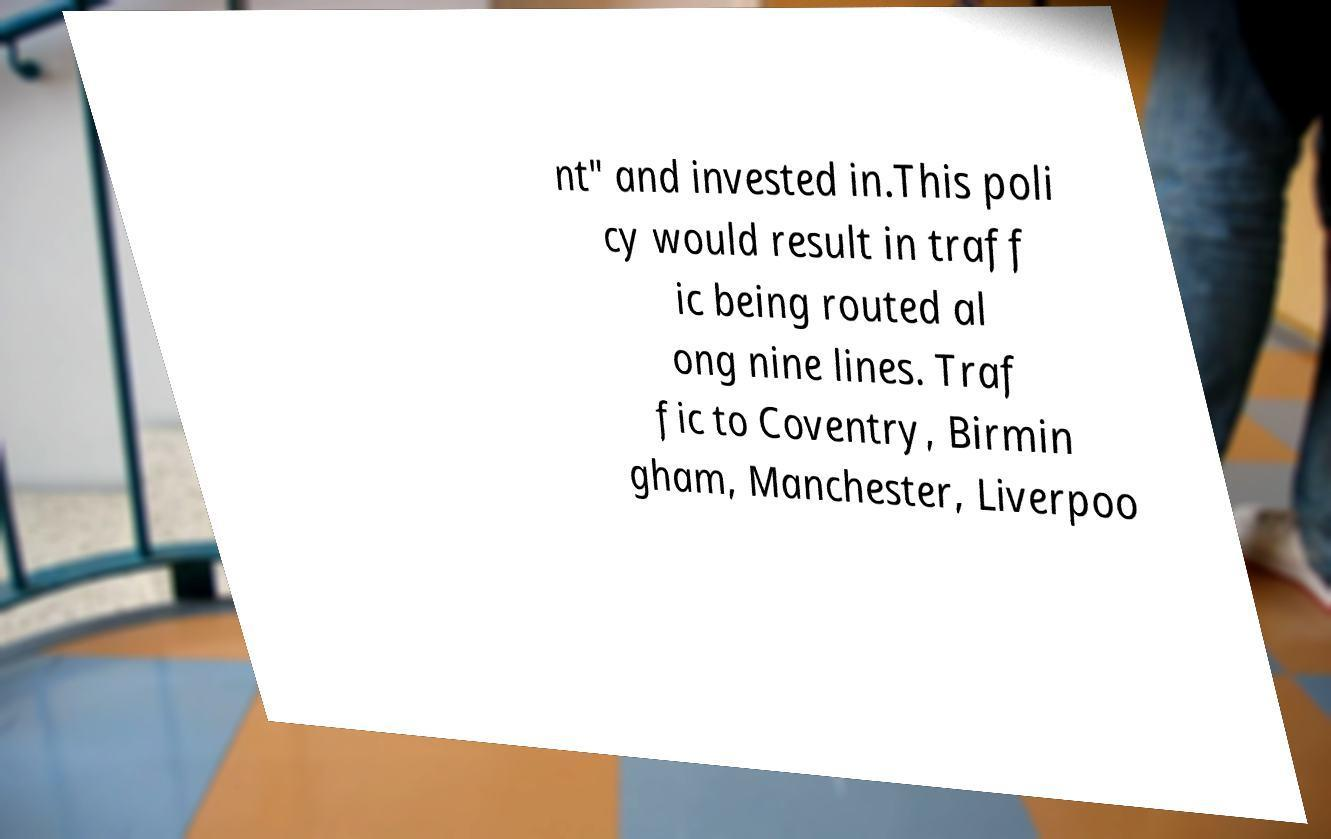I need the written content from this picture converted into text. Can you do that? nt" and invested in.This poli cy would result in traff ic being routed al ong nine lines. Traf fic to Coventry, Birmin gham, Manchester, Liverpoo 